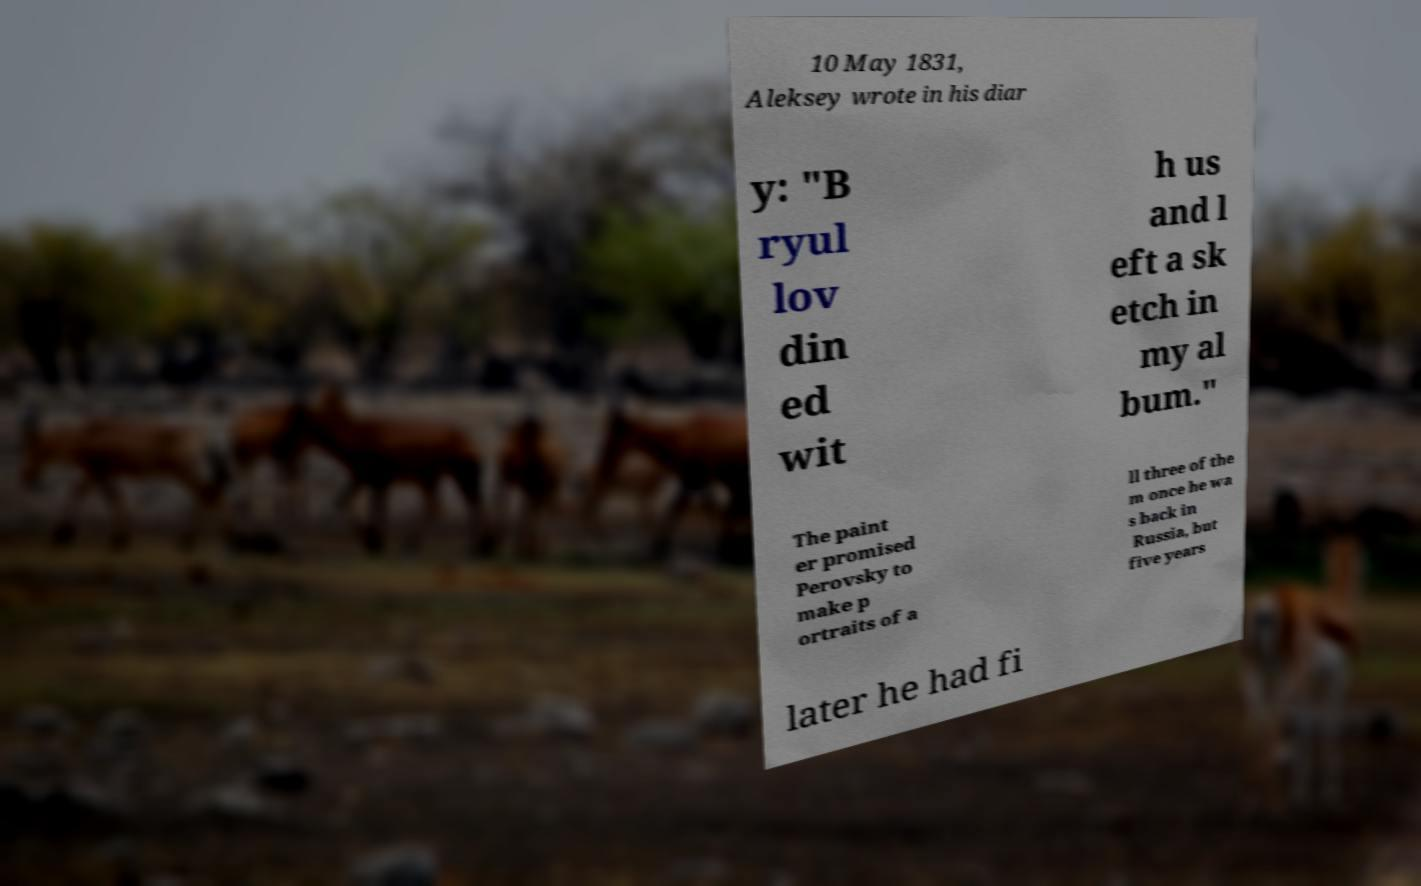Please identify and transcribe the text found in this image. 10 May 1831, Aleksey wrote in his diar y: "B ryul lov din ed wit h us and l eft a sk etch in my al bum." The paint er promised Perovsky to make p ortraits of a ll three of the m once he wa s back in Russia, but five years later he had fi 